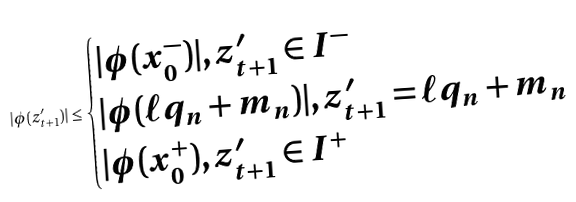<formula> <loc_0><loc_0><loc_500><loc_500>| \phi ( z _ { t + 1 } ^ { \prime } ) | \leq \begin{cases} | \phi ( x _ { 0 } ^ { - } ) | , z _ { t + 1 } ^ { \prime } \in I ^ { - } \\ | \phi ( \ell q _ { n } + m _ { n } ) | , z _ { t + 1 } ^ { \prime } = \ell q _ { n } + m _ { n } \\ | \phi ( x _ { 0 } ^ { + } ) , z _ { t + 1 } ^ { \prime } \in I ^ { + } \end{cases}</formula> 